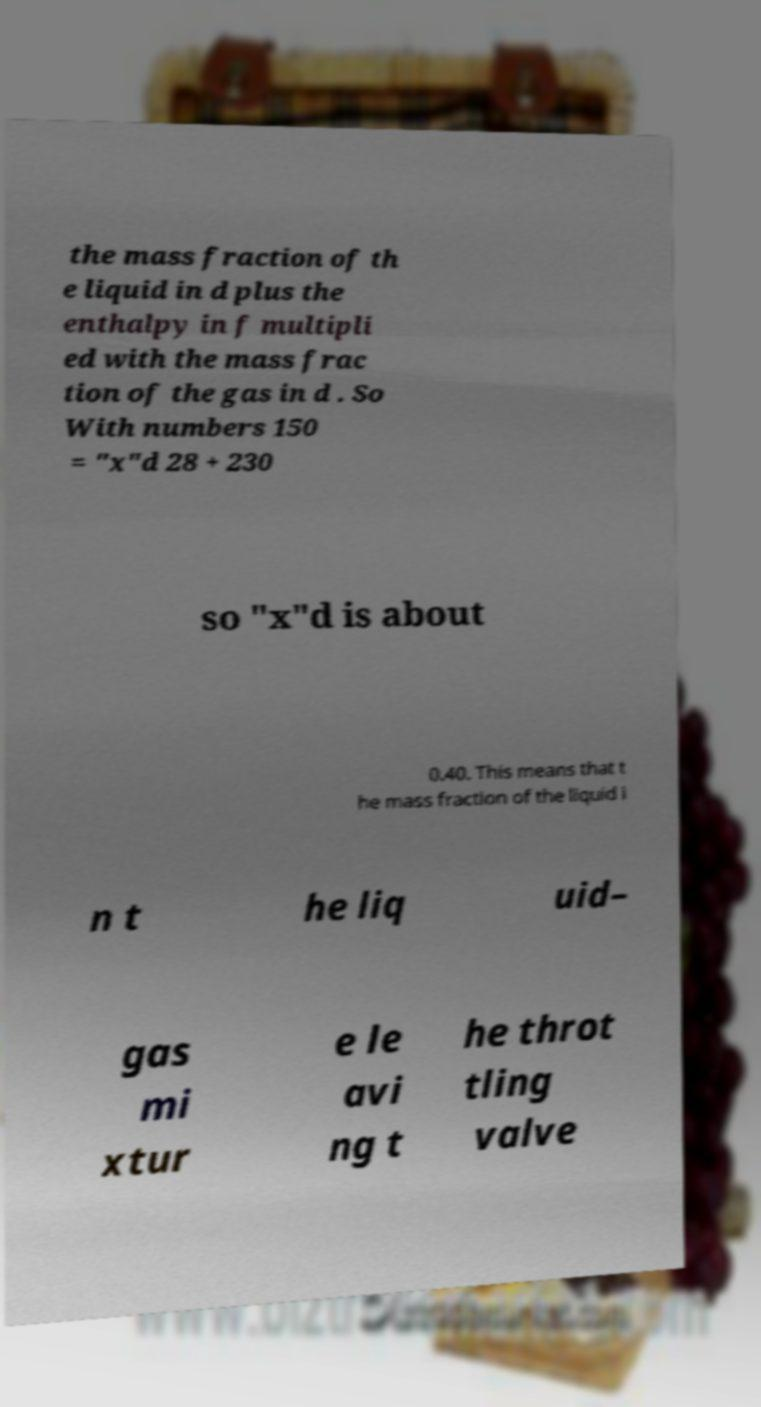Can you accurately transcribe the text from the provided image for me? the mass fraction of th e liquid in d plus the enthalpy in f multipli ed with the mass frac tion of the gas in d . So With numbers 150 = "x"d 28 + 230 so "x"d is about 0.40. This means that t he mass fraction of the liquid i n t he liq uid– gas mi xtur e le avi ng t he throt tling valve 